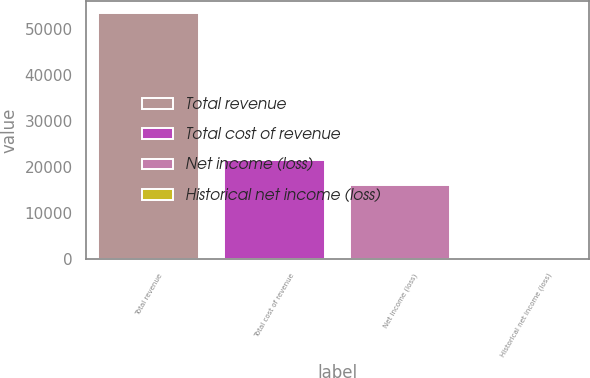Convert chart to OTSL. <chart><loc_0><loc_0><loc_500><loc_500><bar_chart><fcel>Total revenue<fcel>Total cost of revenue<fcel>Net income (loss)<fcel>Historical net income (loss)<nl><fcel>53472<fcel>21509.2<fcel>16162<fcel>0.32<nl></chart> 